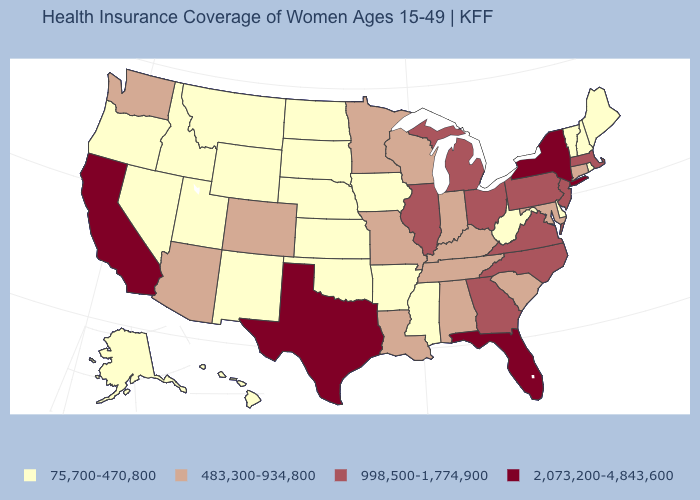Does South Dakota have the lowest value in the USA?
Quick response, please. Yes. How many symbols are there in the legend?
Quick response, please. 4. What is the value of Maine?
Short answer required. 75,700-470,800. Name the states that have a value in the range 483,300-934,800?
Write a very short answer. Alabama, Arizona, Colorado, Connecticut, Indiana, Kentucky, Louisiana, Maryland, Minnesota, Missouri, South Carolina, Tennessee, Washington, Wisconsin. What is the highest value in the USA?
Write a very short answer. 2,073,200-4,843,600. What is the value of Michigan?
Write a very short answer. 998,500-1,774,900. What is the value of Wisconsin?
Keep it brief. 483,300-934,800. Name the states that have a value in the range 2,073,200-4,843,600?
Short answer required. California, Florida, New York, Texas. Among the states that border Michigan , does Indiana have the lowest value?
Quick response, please. Yes. What is the value of Oregon?
Short answer required. 75,700-470,800. Does Montana have a higher value than Nevada?
Short answer required. No. Among the states that border Massachusetts , which have the lowest value?
Write a very short answer. New Hampshire, Rhode Island, Vermont. Name the states that have a value in the range 483,300-934,800?
Be succinct. Alabama, Arizona, Colorado, Connecticut, Indiana, Kentucky, Louisiana, Maryland, Minnesota, Missouri, South Carolina, Tennessee, Washington, Wisconsin. Which states have the lowest value in the MidWest?
Quick response, please. Iowa, Kansas, Nebraska, North Dakota, South Dakota. What is the value of Kentucky?
Concise answer only. 483,300-934,800. 